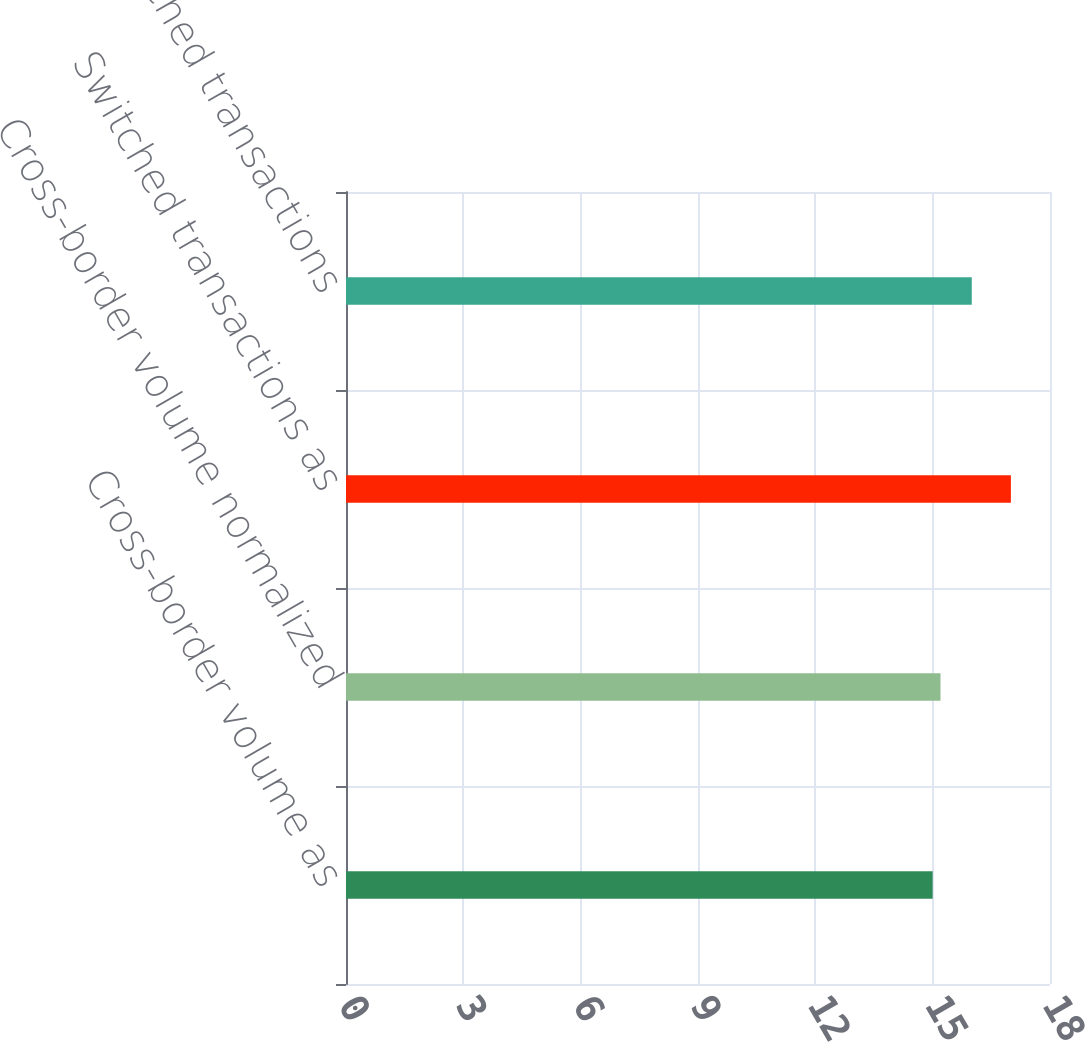Convert chart. <chart><loc_0><loc_0><loc_500><loc_500><bar_chart><fcel>Cross-border volume as<fcel>Cross-border volume normalized<fcel>Switched transactions as<fcel>Switched transactions<nl><fcel>15<fcel>15.2<fcel>17<fcel>16<nl></chart> 